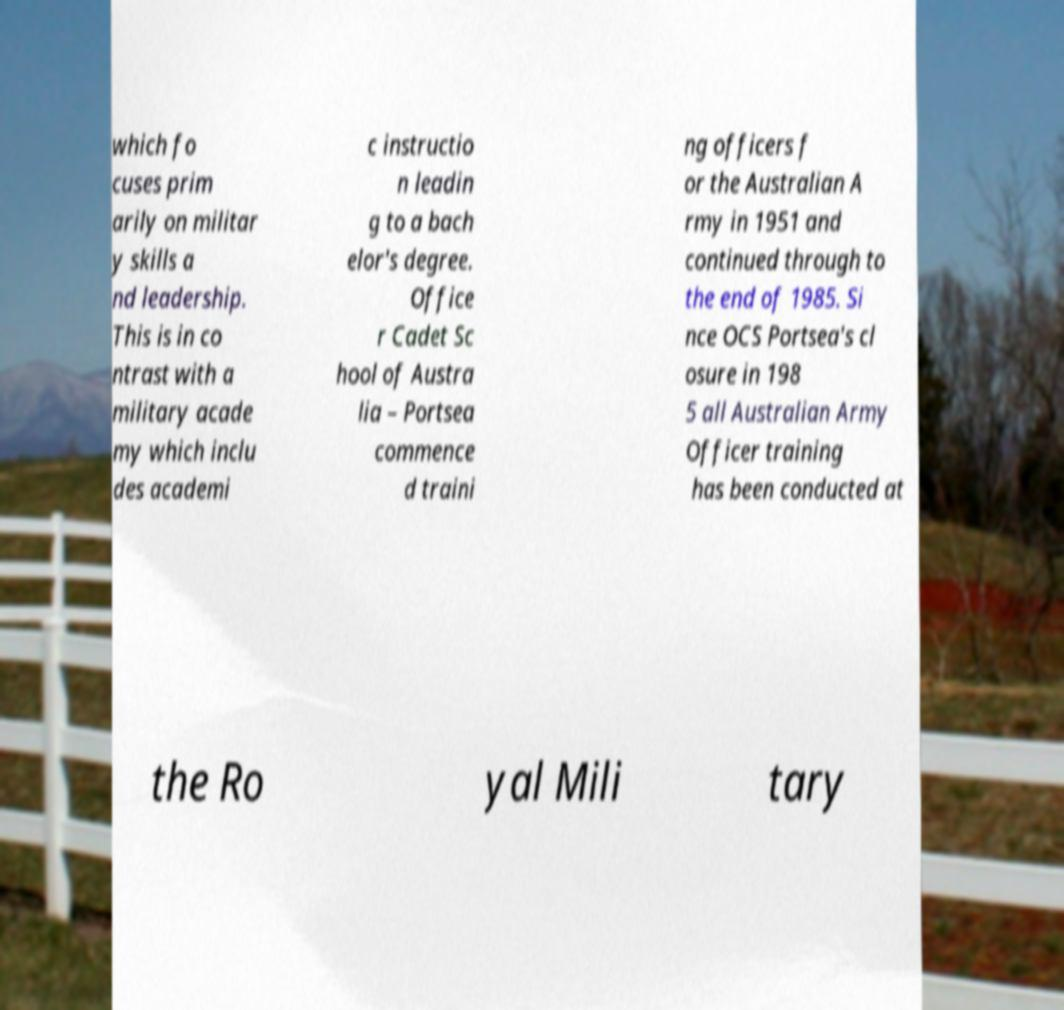Can you accurately transcribe the text from the provided image for me? which fo cuses prim arily on militar y skills a nd leadership. This is in co ntrast with a military acade my which inclu des academi c instructio n leadin g to a bach elor's degree. Office r Cadet Sc hool of Austra lia – Portsea commence d traini ng officers f or the Australian A rmy in 1951 and continued through to the end of 1985. Si nce OCS Portsea's cl osure in 198 5 all Australian Army Officer training has been conducted at the Ro yal Mili tary 